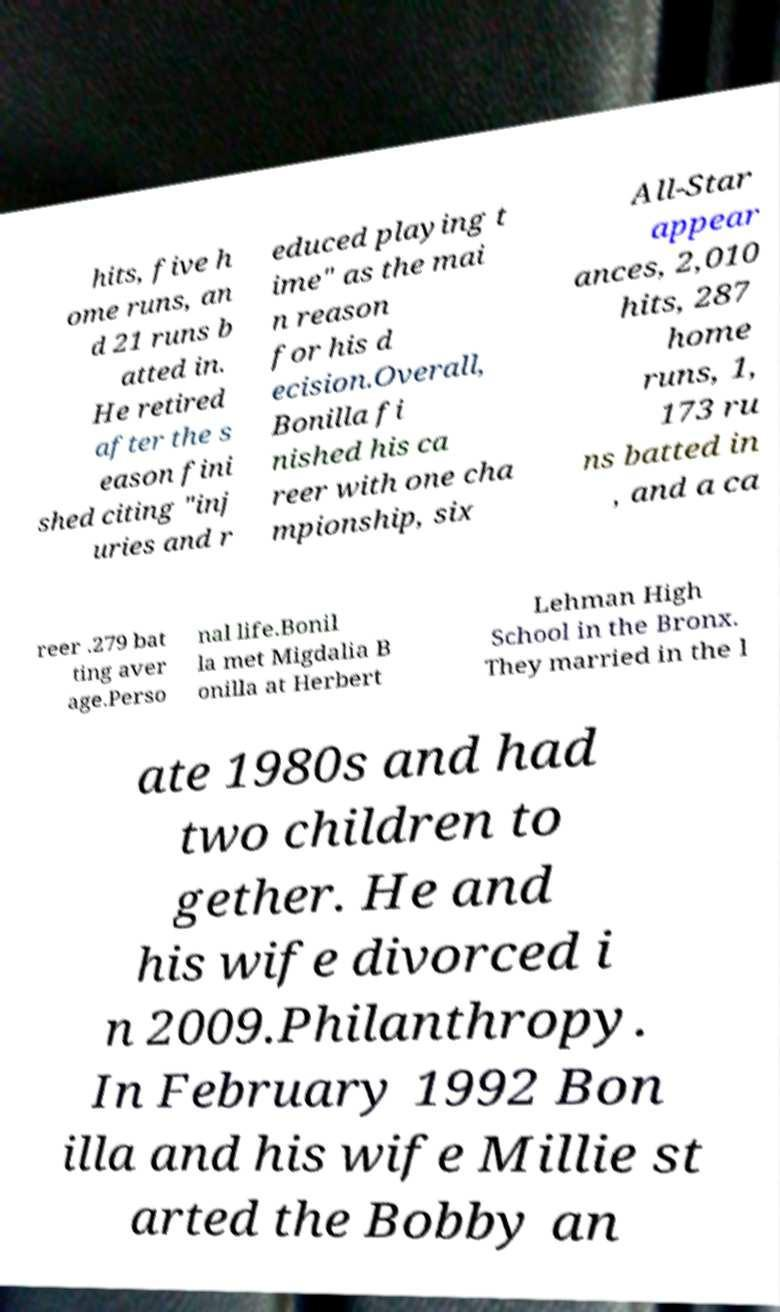Can you read and provide the text displayed in the image?This photo seems to have some interesting text. Can you extract and type it out for me? hits, five h ome runs, an d 21 runs b atted in. He retired after the s eason fini shed citing "inj uries and r educed playing t ime" as the mai n reason for his d ecision.Overall, Bonilla fi nished his ca reer with one cha mpionship, six All-Star appear ances, 2,010 hits, 287 home runs, 1, 173 ru ns batted in , and a ca reer .279 bat ting aver age.Perso nal life.Bonil la met Migdalia B onilla at Herbert Lehman High School in the Bronx. They married in the l ate 1980s and had two children to gether. He and his wife divorced i n 2009.Philanthropy. In February 1992 Bon illa and his wife Millie st arted the Bobby an 